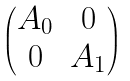Convert formula to latex. <formula><loc_0><loc_0><loc_500><loc_500>\begin{pmatrix} A _ { 0 } & 0 \\ 0 & A _ { 1 } \end{pmatrix}</formula> 